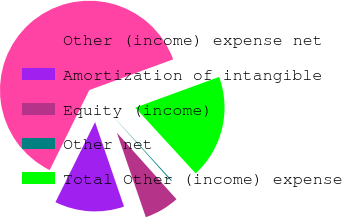Convert chart. <chart><loc_0><loc_0><loc_500><loc_500><pie_chart><fcel>Other (income) expense net<fcel>Amortization of intangible<fcel>Equity (income)<fcel>Other net<fcel>Total Other (income) expense<nl><fcel>62.11%<fcel>12.57%<fcel>6.38%<fcel>0.19%<fcel>18.76%<nl></chart> 